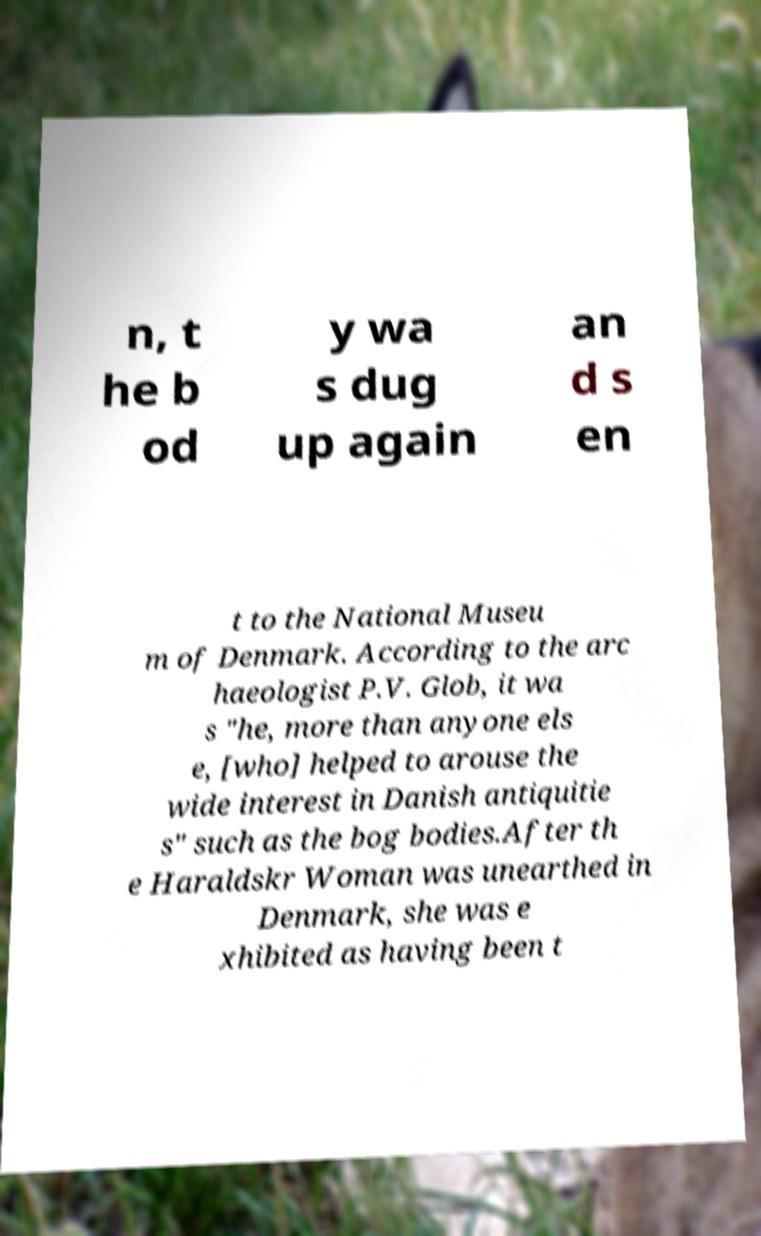Could you assist in decoding the text presented in this image and type it out clearly? n, t he b od y wa s dug up again an d s en t to the National Museu m of Denmark. According to the arc haeologist P.V. Glob, it wa s "he, more than anyone els e, [who] helped to arouse the wide interest in Danish antiquitie s" such as the bog bodies.After th e Haraldskr Woman was unearthed in Denmark, she was e xhibited as having been t 